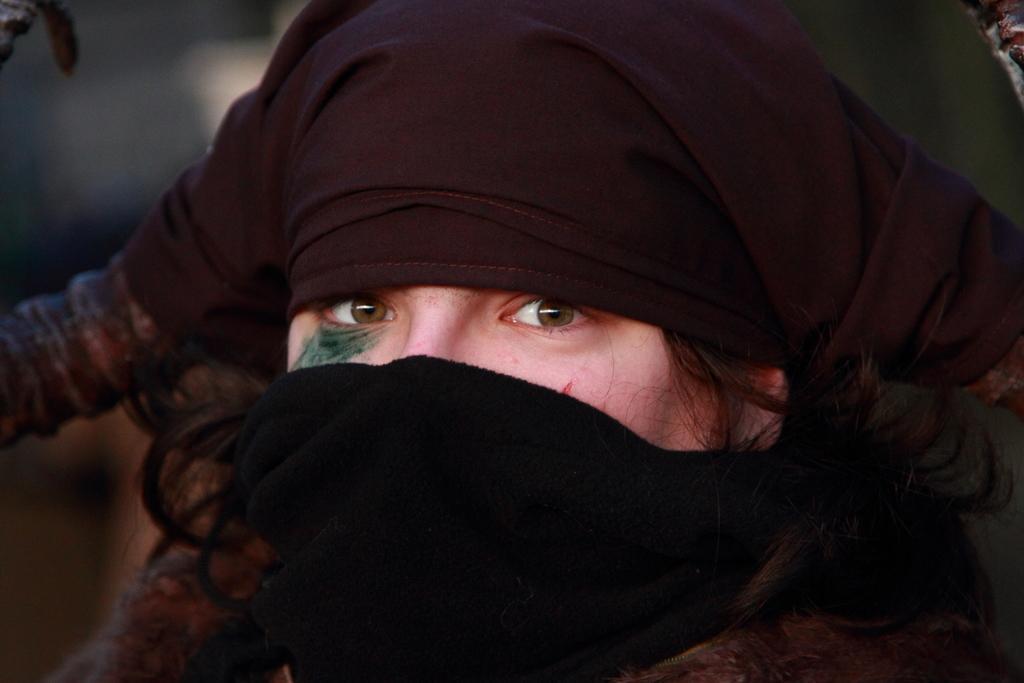What is the main subject of the image? There is a person in the image. What is the person wearing on their face and head? The person is wearing a mask. How is the background of the person depicted in the image? The background of the person is blurred. What type of swim can be seen in the background of the image? There is no swim or swimming pool visible in the background of the image. Is there an alarm going off in the image? There is no indication of an alarm or any sound in the image. 